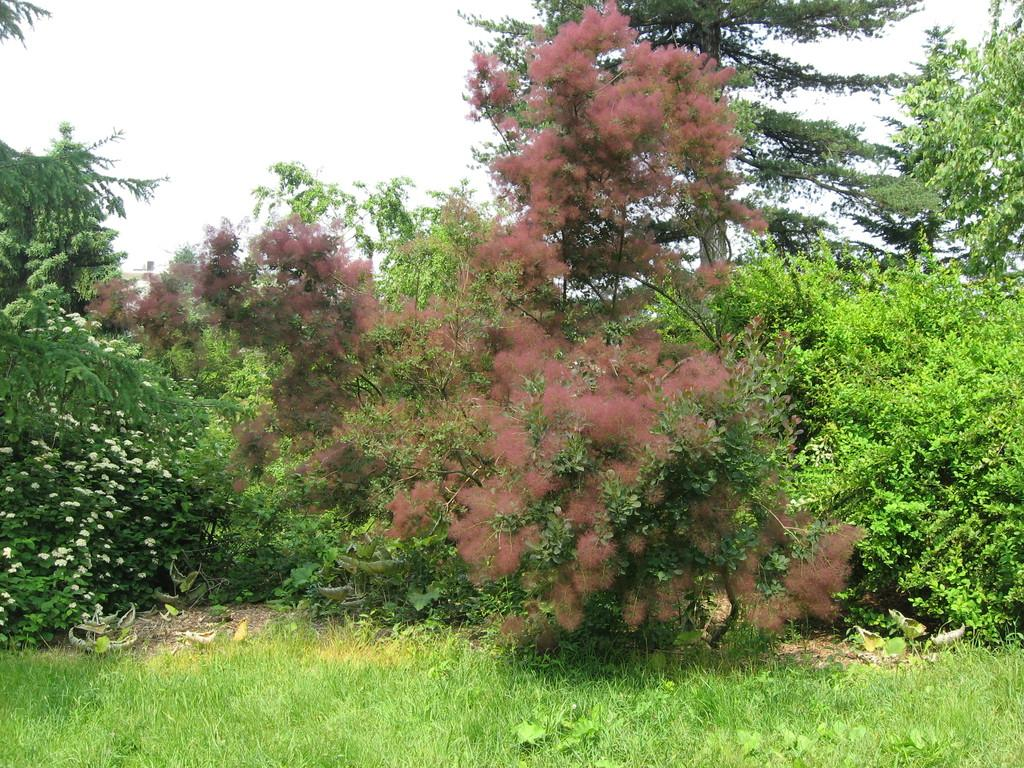What type of vegetation is present on the ground in the image? There is grass on the ground in the image. What can be seen in the background of the image? There are trees and the sky visible in the background of the image. What type of park is the grass located in the image? There is no indication that the grass is located in a park in the image. 